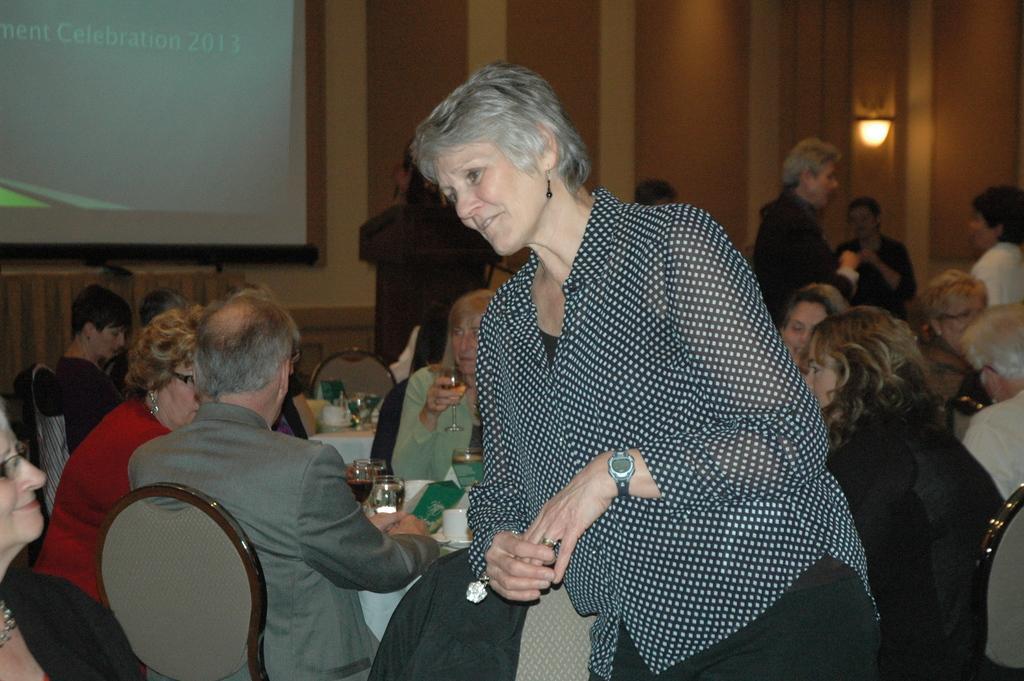In one or two sentences, can you explain what this image depicts? In this image there are a group of people who are sitting on chairs, and some of them are standing and also we could see some tables. On the table there are some glasses, cups and in the background there is a wall, screen and light. 